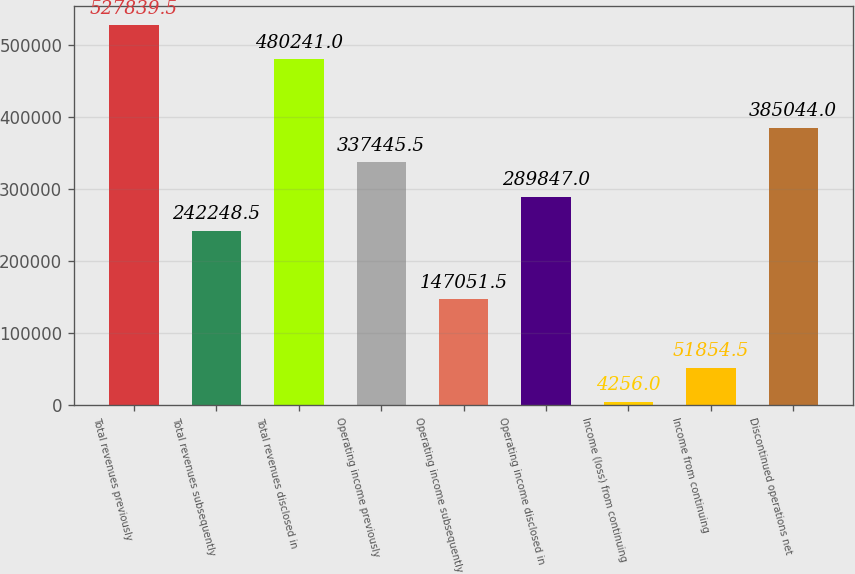Convert chart to OTSL. <chart><loc_0><loc_0><loc_500><loc_500><bar_chart><fcel>Total revenues previously<fcel>Total revenues subsequently<fcel>Total revenues disclosed in<fcel>Operating income previously<fcel>Operating income subsequently<fcel>Operating income disclosed in<fcel>Income (loss) from continuing<fcel>Income from continuing<fcel>Discontinued operations net<nl><fcel>527840<fcel>242248<fcel>480241<fcel>337446<fcel>147052<fcel>289847<fcel>4256<fcel>51854.5<fcel>385044<nl></chart> 